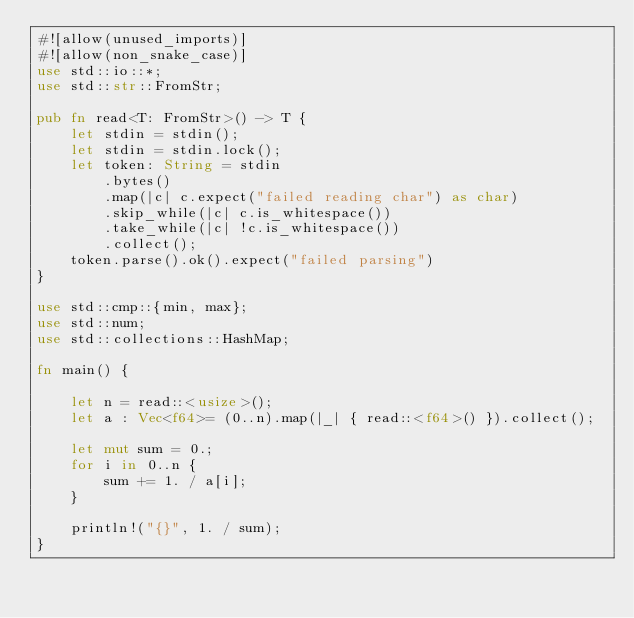<code> <loc_0><loc_0><loc_500><loc_500><_Rust_>#![allow(unused_imports)]
#![allow(non_snake_case)]
use std::io::*;
use std::str::FromStr;
 
pub fn read<T: FromStr>() -> T {
    let stdin = stdin();
    let stdin = stdin.lock();
    let token: String = stdin
        .bytes()
        .map(|c| c.expect("failed reading char") as char)
        .skip_while(|c| c.is_whitespace())
        .take_while(|c| !c.is_whitespace())
        .collect();
    token.parse().ok().expect("failed parsing")
}
 
use std::cmp::{min, max};
use std::num;
use std::collections::HashMap;
 
fn main() {
    
    let n = read::<usize>();
    let a : Vec<f64>= (0..n).map(|_| { read::<f64>() }).collect();
    
    let mut sum = 0.;
    for i in 0..n {
        sum += 1. / a[i];
    }
    
    println!("{}", 1. / sum);
}
</code> 